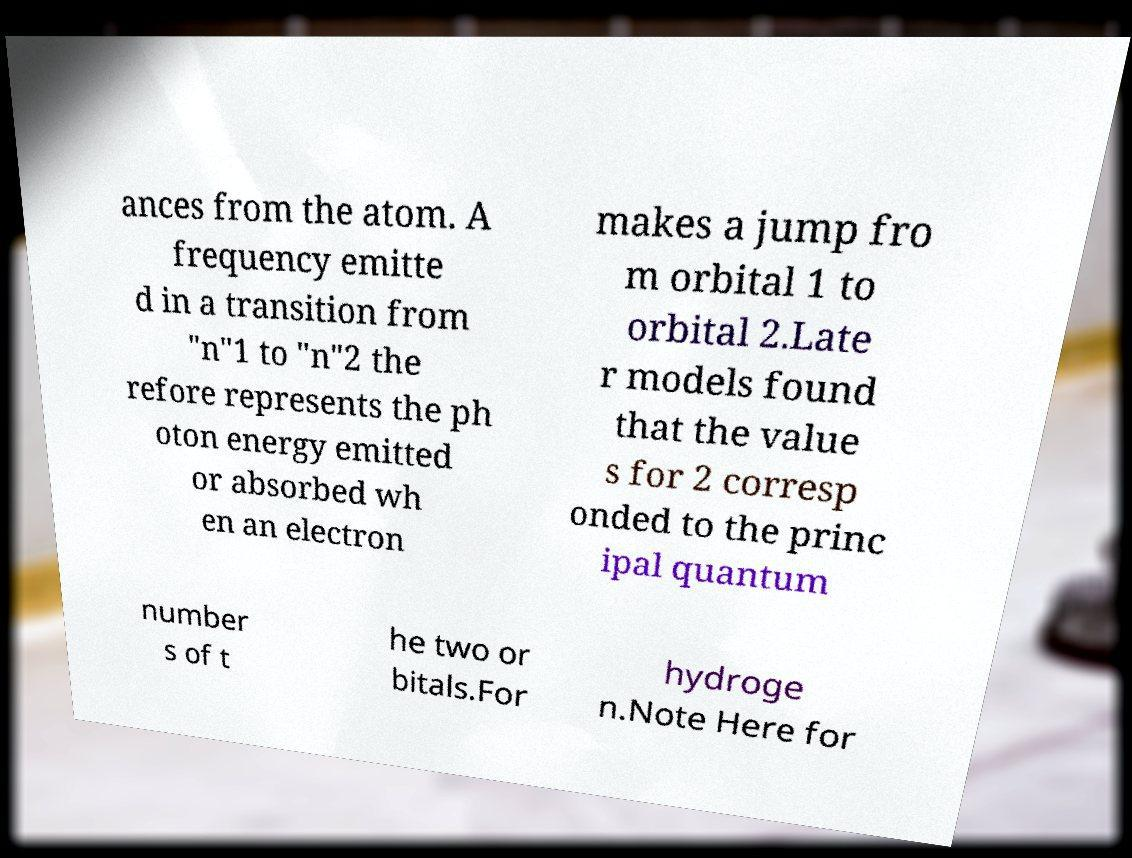For documentation purposes, I need the text within this image transcribed. Could you provide that? ances from the atom. A frequency emitte d in a transition from "n"1 to "n"2 the refore represents the ph oton energy emitted or absorbed wh en an electron makes a jump fro m orbital 1 to orbital 2.Late r models found that the value s for 2 corresp onded to the princ ipal quantum number s of t he two or bitals.For hydroge n.Note Here for 